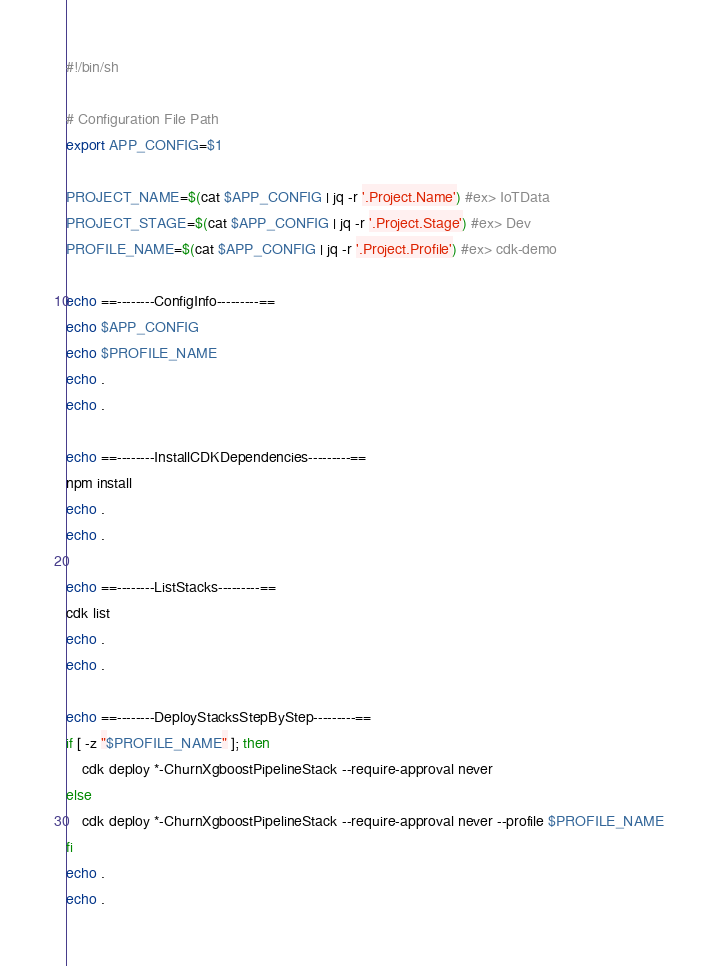<code> <loc_0><loc_0><loc_500><loc_500><_Bash_>#!/bin/sh

# Configuration File Path
export APP_CONFIG=$1

PROJECT_NAME=$(cat $APP_CONFIG | jq -r '.Project.Name') #ex> IoTData
PROJECT_STAGE=$(cat $APP_CONFIG | jq -r '.Project.Stage') #ex> Dev
PROFILE_NAME=$(cat $APP_CONFIG | jq -r '.Project.Profile') #ex> cdk-demo

echo ==--------ConfigInfo---------==
echo $APP_CONFIG
echo $PROFILE_NAME
echo .
echo .

echo ==--------InstallCDKDependencies---------==
npm install
echo .
echo .

echo ==--------ListStacks---------==
cdk list
echo .
echo .

echo ==--------DeployStacksStepByStep---------==
if [ -z "$PROFILE_NAME" ]; then
    cdk deploy *-ChurnXgboostPipelineStack --require-approval never
else
    cdk deploy *-ChurnXgboostPipelineStack --require-approval never --profile $PROFILE_NAME
fi
echo .
echo .
</code> 